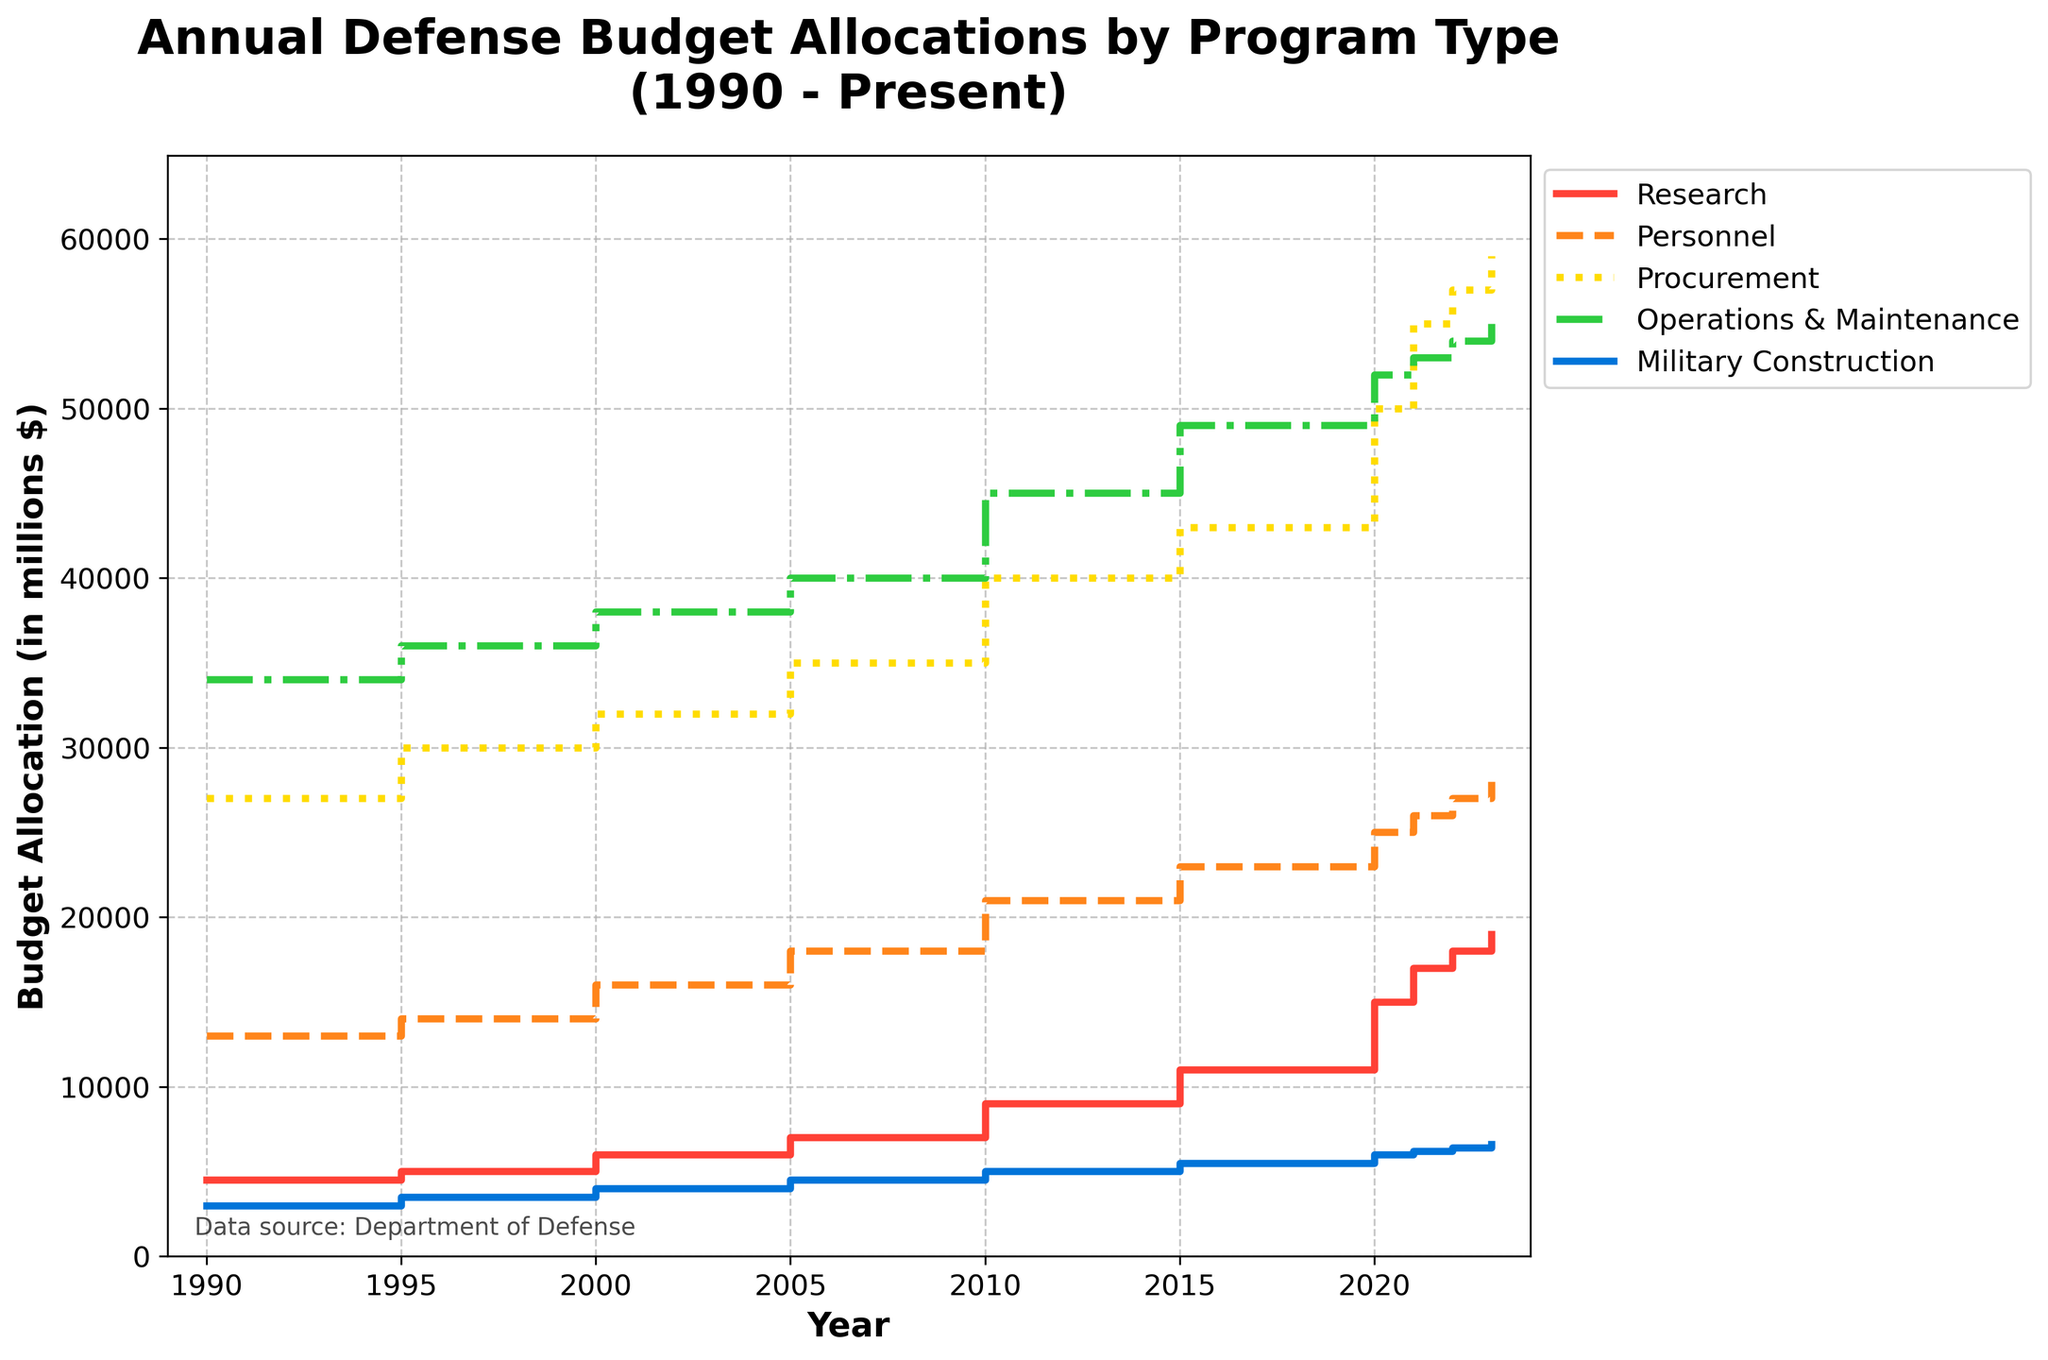What is the title of the figure? The title is usually located at the top of the figure and provides a summary of what the plot is about. This one reads "Annual Defense Budget Allocations by Program Type (1990 - Present)"
Answer: Annual Defense Budget Allocations by Program Type (1990 - Present) What does the y-axis represent? The y-axis label typically states what is being measured on that axis. In this plot, it is labeled "Budget Allocation (in millions $)" indicating the monetary amount allocated to each defense program in millions of dollars.
Answer: Budget Allocation (in millions $) Which program type had the highest budget allocation in 2023? By looking at the plot values for the year 2023, we see the highest step for the Procurement program, which is above 59,000 million $.
Answer: Procurement How has the budget for Military Construction changed from 1990 to 2023? Observe the Military Construction steps for the years 1990 (3,000 million $) and 2023 (6,600 million $). The difference is 6,600 - 3,000 = 3,600 million $, indicating a steady increase.
Answer: Increased by 3,600 million $ In which year did the budget allocation for Research exceed Personnel for the first time? Look for the first year where the line for Research steps above the line for Personnel. This occurs in 2020, where Research is at 15,000 million $ and Personnel is at 25,000 million $.
Answer: 2020 What is the total defense budget allocation for all program types in 2010? Sum the values for each program type in 2010: 9,000 (Research) + 21,000 (Personnel) + 40,000 (Procurement) + 45,000 (Operations & Maintenance) + 5,000 (Military Construction). The total is 120,000 million $.
Answer: 120,000 million $ When did the Operations & Maintenance budget first surpass 50,000 million $? The line for Operations & Maintenance crosses the 50,000 million $ mark between 2015 (49,000 million $) and 2020 (52,000 million $), so the year is 2020.
Answer: 2020 